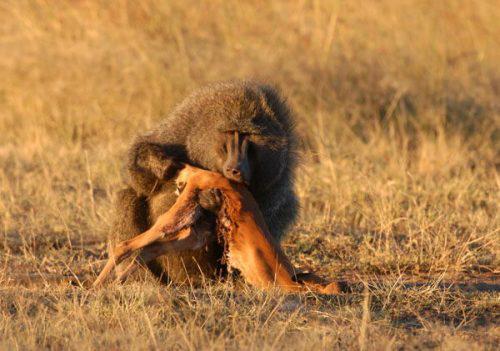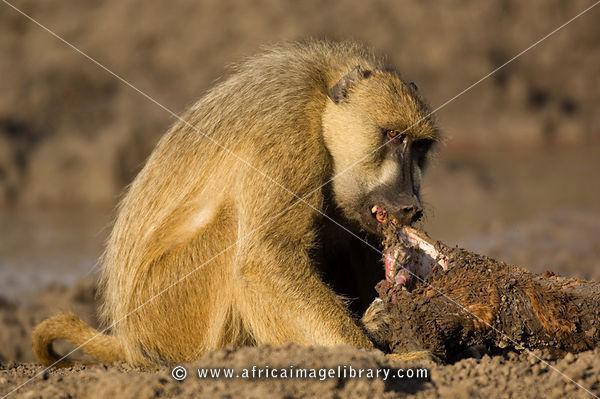The first image is the image on the left, the second image is the image on the right. For the images displayed, is the sentence "An image show a right-facing monkey with wide-opened mouth baring its fangs." factually correct? Answer yes or no. No. The first image is the image on the left, the second image is the image on the right. For the images shown, is this caption "At least one monkey has its mouth wide open with sharp teeth visible." true? Answer yes or no. No. 